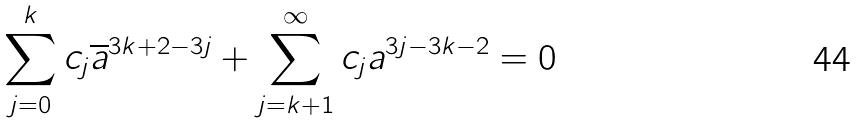Convert formula to latex. <formula><loc_0><loc_0><loc_500><loc_500>\sum _ { j = 0 } ^ { k } c _ { j } \overline { a } ^ { 3 k + 2 - 3 j } + \sum _ { j = k + 1 } ^ { \infty } c _ { j } a ^ { 3 j - 3 k - 2 } = 0</formula> 